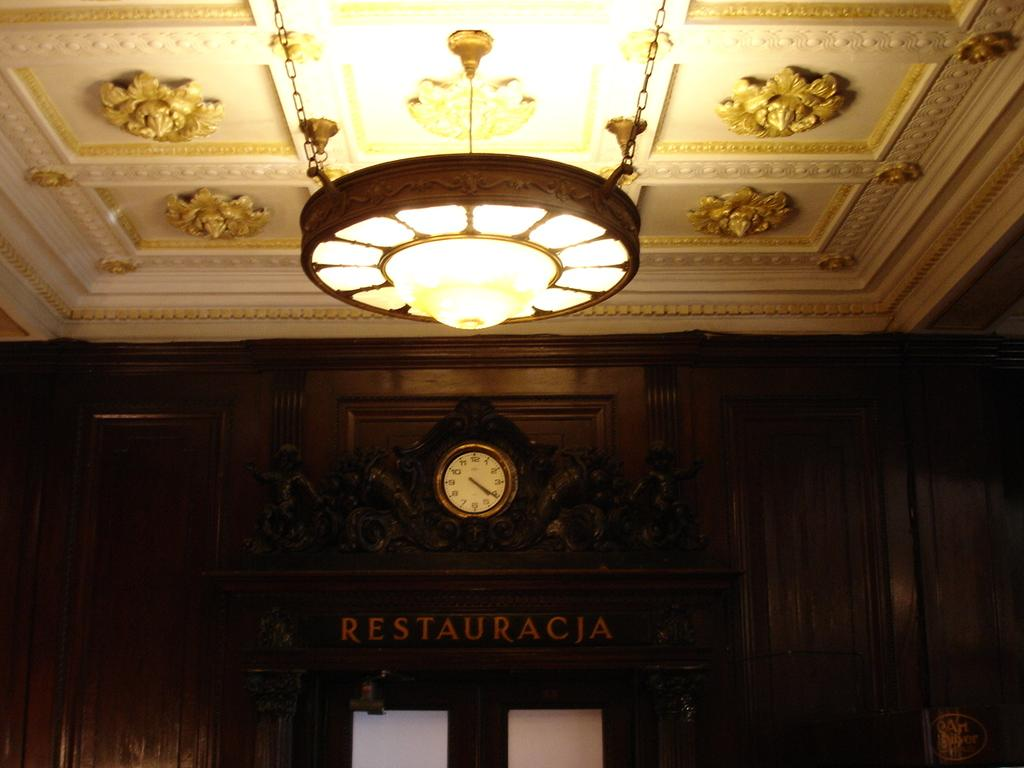<image>
Render a clear and concise summary of the photo. A gold framed clock hangs over a sign reading Restauracja. 